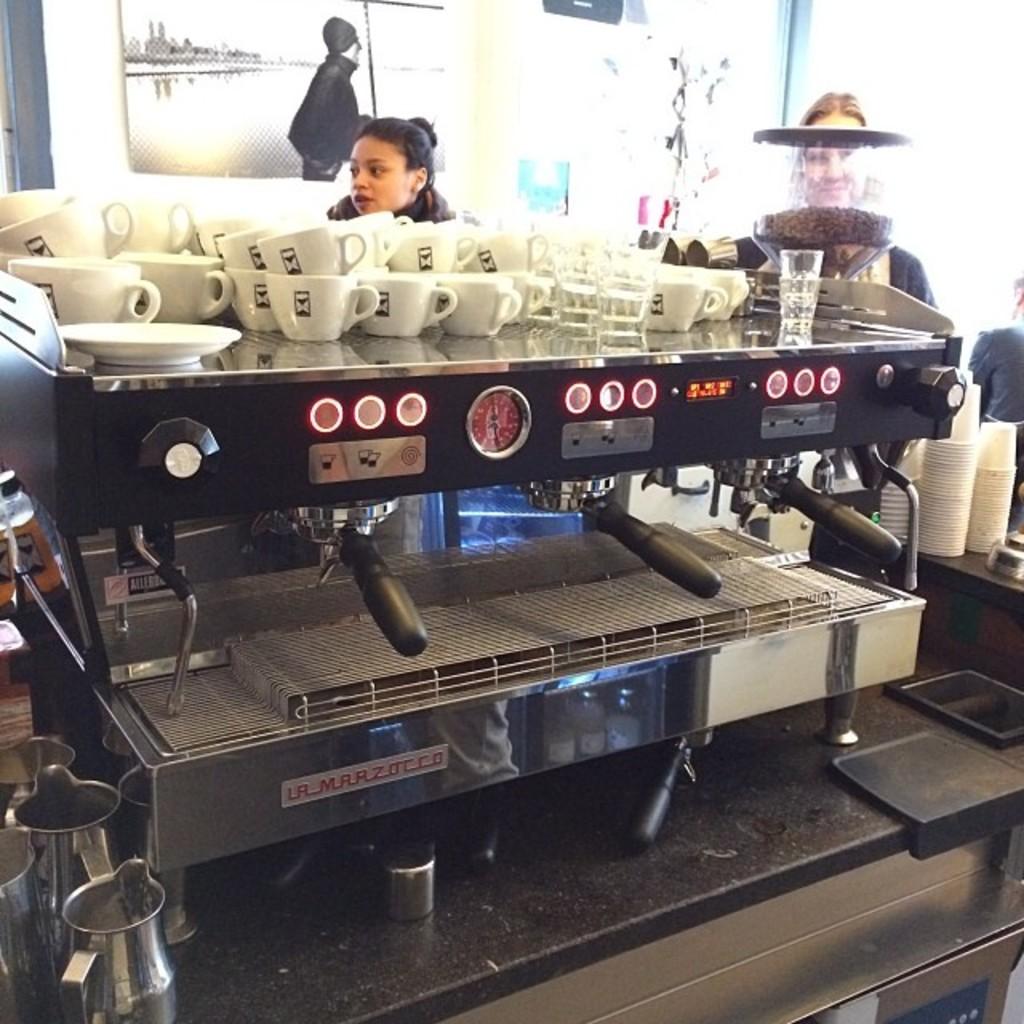What is the brand name on the espresso machine?
Provide a short and direct response. Unanswerable. 